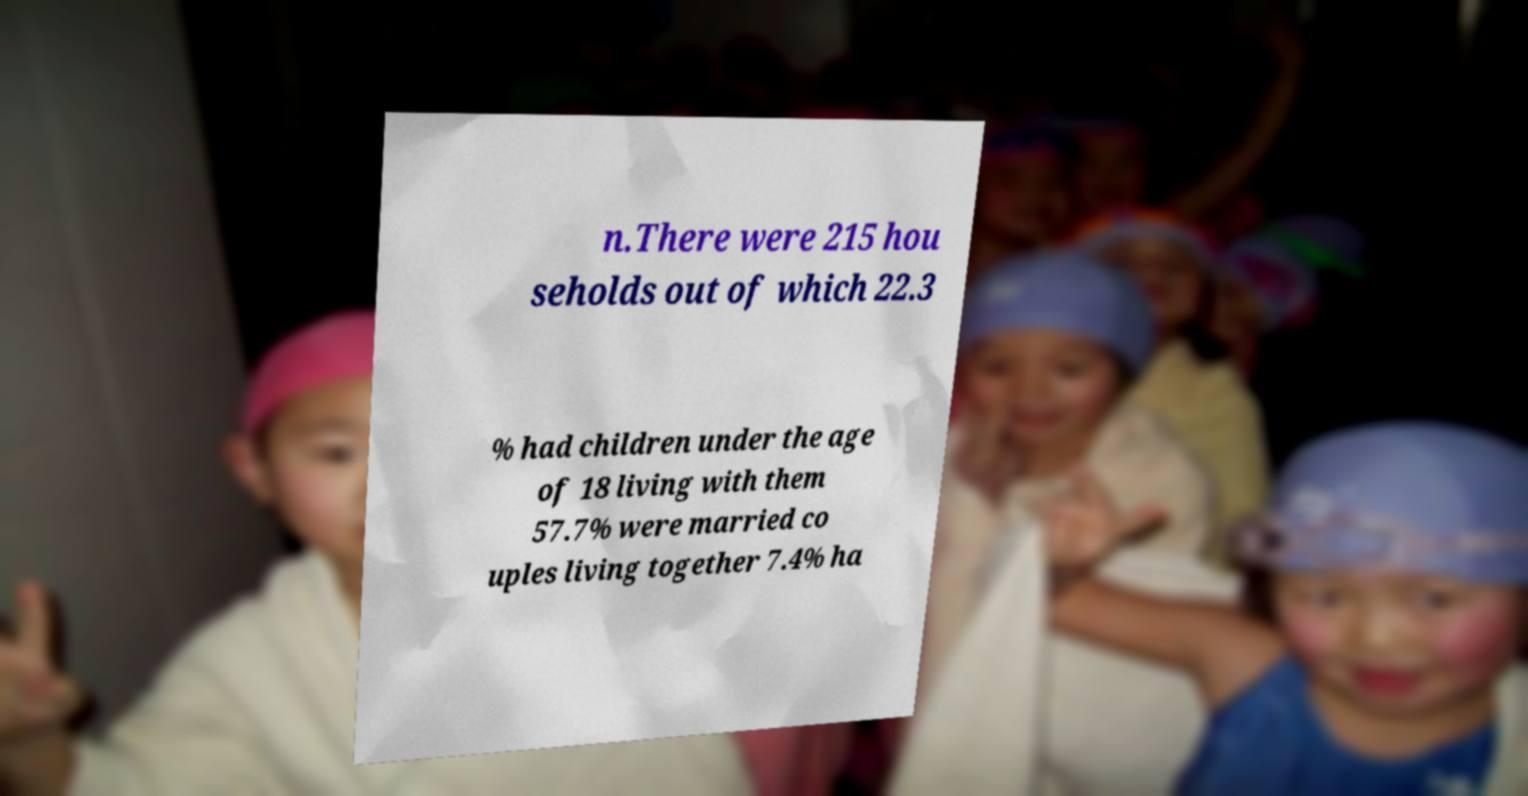Can you accurately transcribe the text from the provided image for me? n.There were 215 hou seholds out of which 22.3 % had children under the age of 18 living with them 57.7% were married co uples living together 7.4% ha 